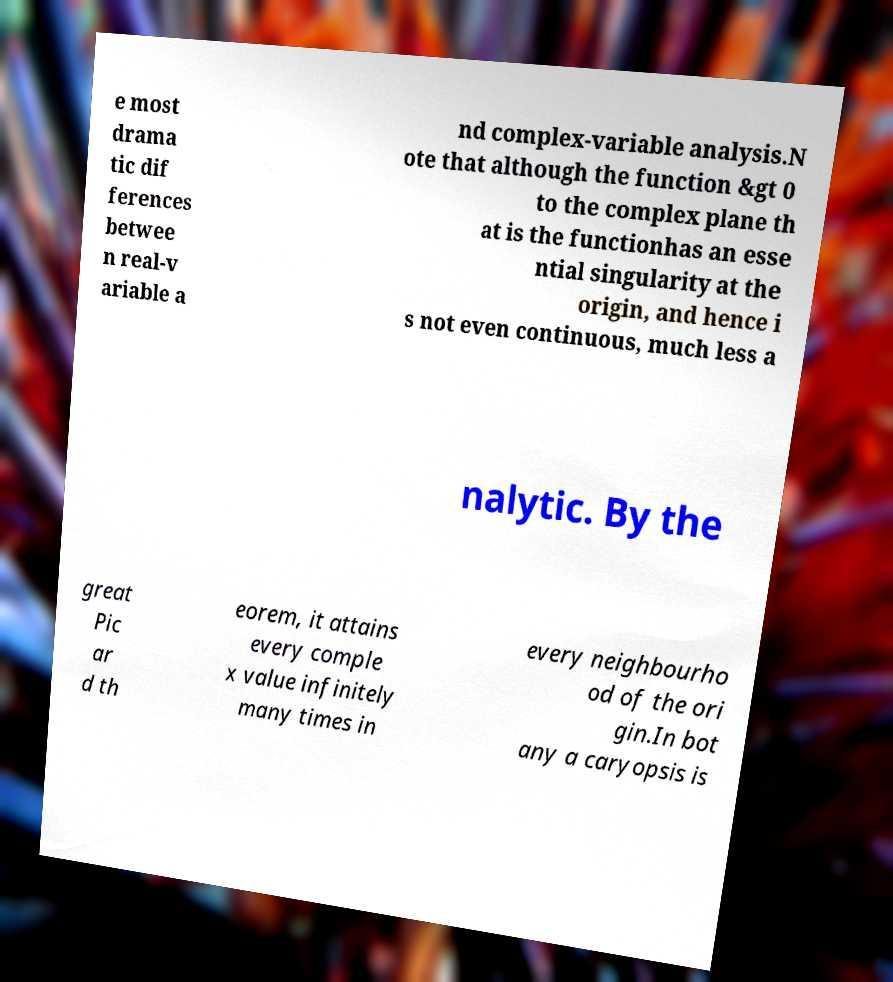For documentation purposes, I need the text within this image transcribed. Could you provide that? e most drama tic dif ferences betwee n real-v ariable a nd complex-variable analysis.N ote that although the function &gt 0 to the complex plane th at is the functionhas an esse ntial singularity at the origin, and hence i s not even continuous, much less a nalytic. By the great Pic ar d th eorem, it attains every comple x value infinitely many times in every neighbourho od of the ori gin.In bot any a caryopsis is 